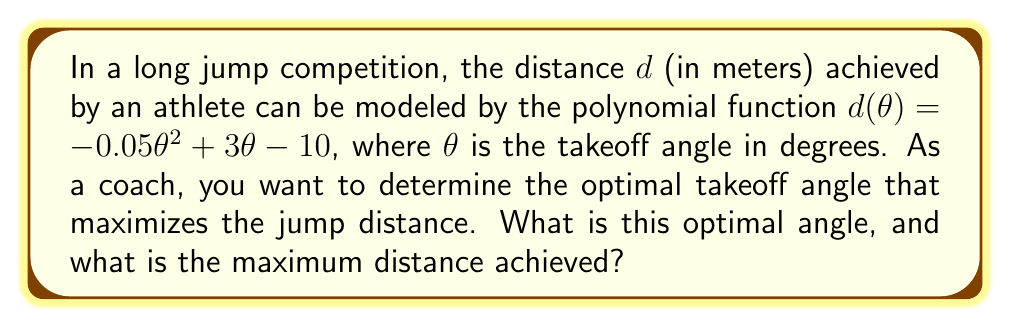Could you help me with this problem? To find the optimal takeoff angle, we need to follow these steps:

1) The function $d(\theta) = -0.05\theta^2 + 3\theta - 10$ is a quadratic function, which forms a parabola when graphed.

2) The optimal angle will occur at the vertex of this parabola, which represents the maximum of the function.

3) For a quadratic function in the form $f(x) = ax^2 + bx + c$, the x-coordinate of the vertex is given by $x = -\frac{b}{2a}$.

4) In our case, $a = -0.05$, $b = 3$, and $c = -10$.

5) Substituting these values:

   $\theta_{optimal} = -\frac{3}{2(-0.05)} = \frac{3}{0.1} = 30$

6) Therefore, the optimal takeoff angle is 30 degrees.

7) To find the maximum distance, we substitute this angle back into our original function:

   $d(30) = -0.05(30)^2 + 3(30) - 10$
          $= -0.05(900) + 90 - 10$
          $= -45 + 90 - 10$
          $= 35$

8) Thus, the maximum distance achieved is 35 meters.
Answer: 30°, 35 m 